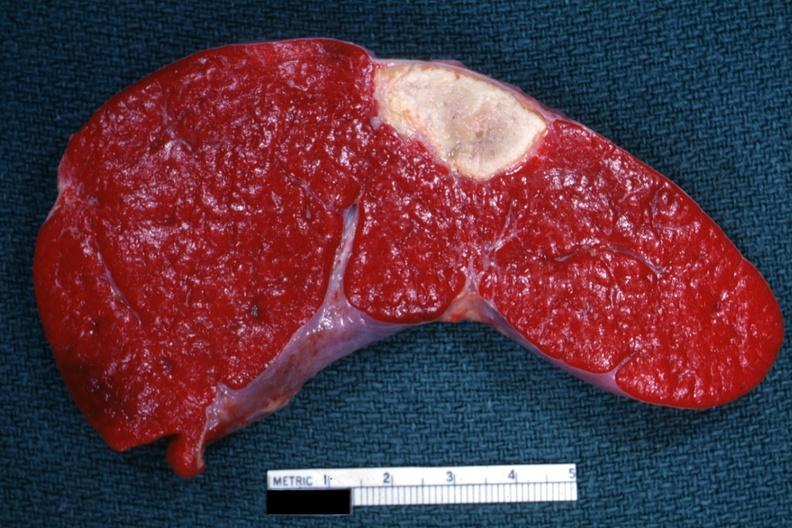what does this image show?
Answer the question using a single word or phrase. Excellent example of old spleen infarct 